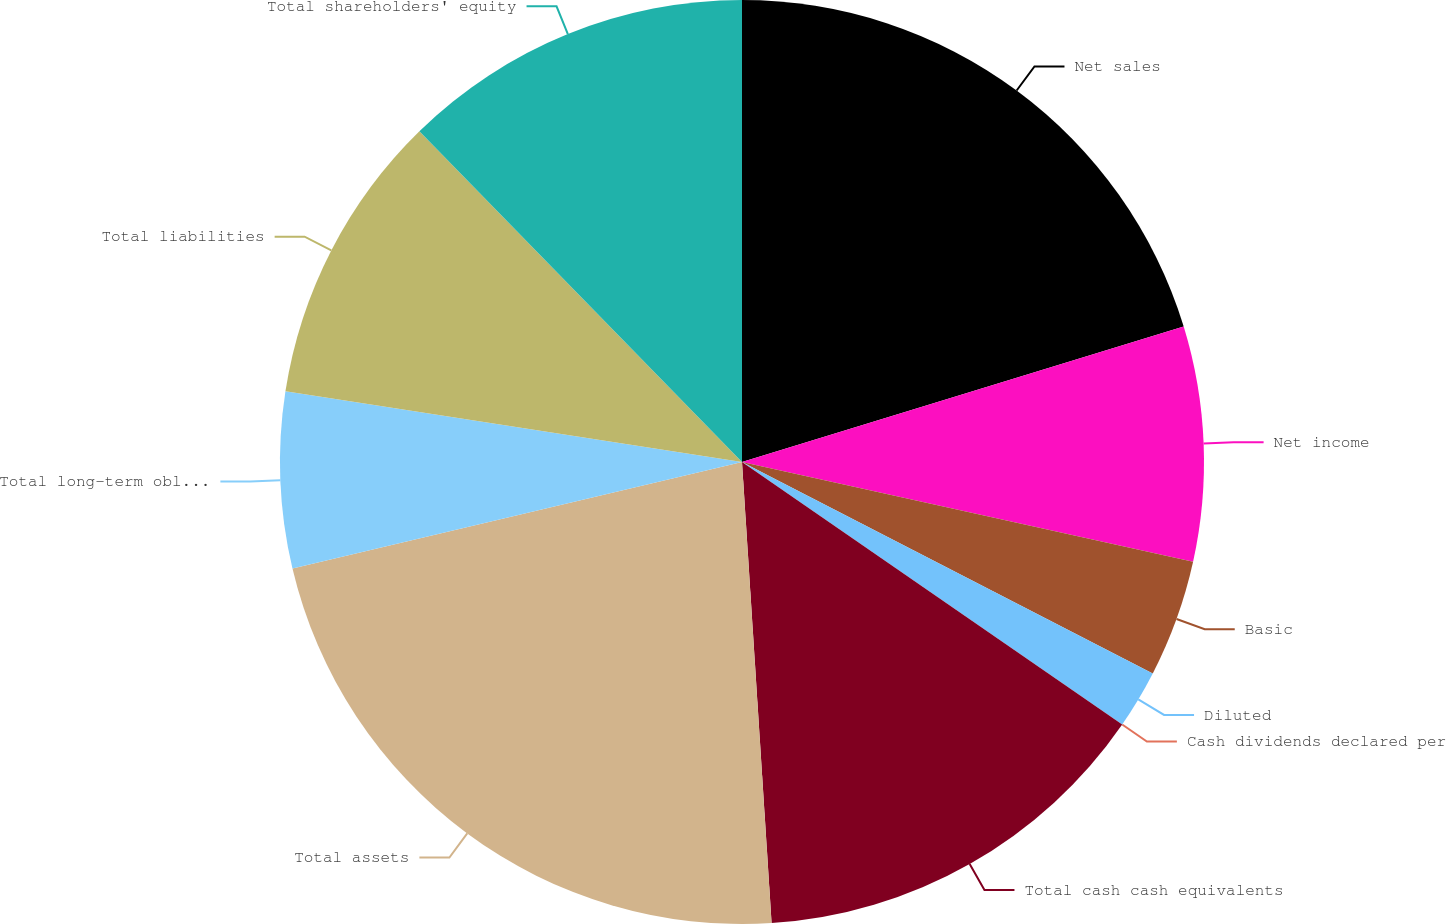Convert chart. <chart><loc_0><loc_0><loc_500><loc_500><pie_chart><fcel>Net sales<fcel>Net income<fcel>Basic<fcel>Diluted<fcel>Cash dividends declared per<fcel>Total cash cash equivalents<fcel>Total assets<fcel>Total long-term obligations<fcel>Total liabilities<fcel>Total shareholders' equity<nl><fcel>20.26%<fcel>8.2%<fcel>4.1%<fcel>2.05%<fcel>0.0%<fcel>14.36%<fcel>22.31%<fcel>6.15%<fcel>10.25%<fcel>12.3%<nl></chart> 